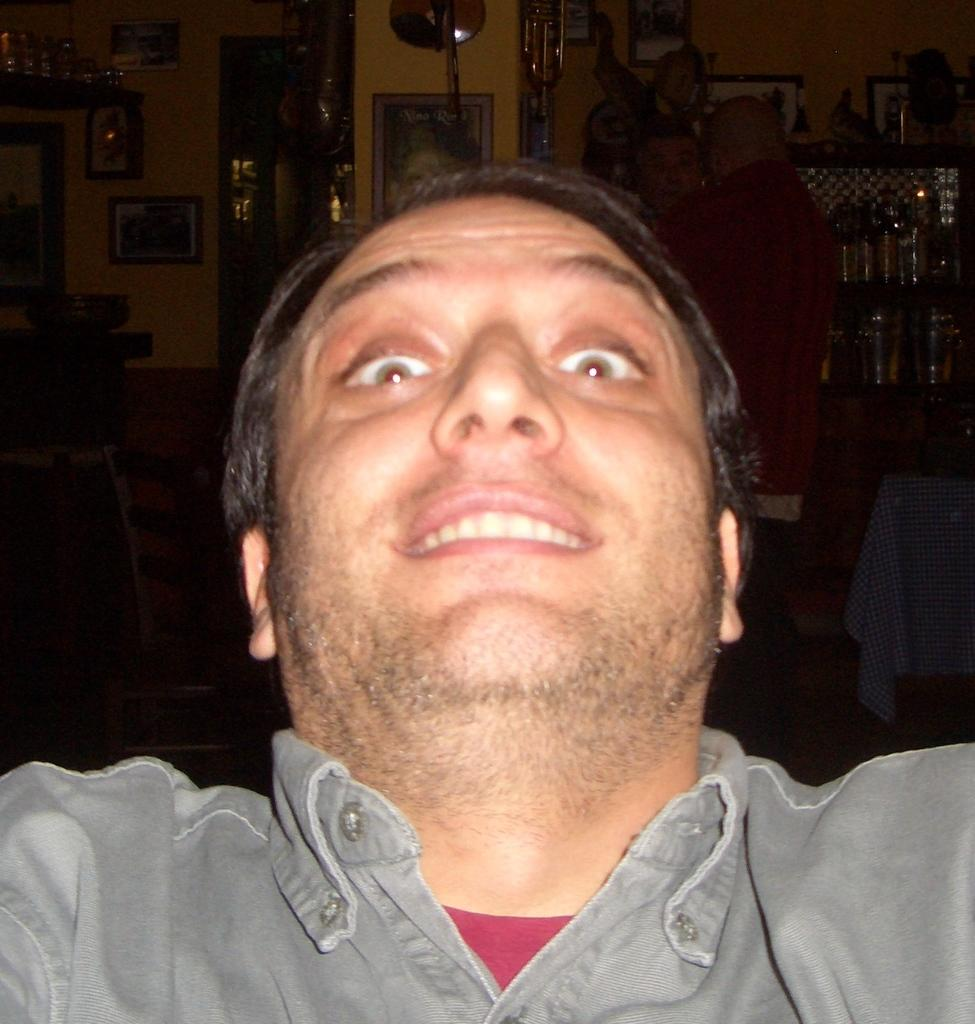Who is present in the image? There is a man in the image. What is the man doing in the image? The man is smiling in the image. What is the man wearing in the image? The man is wearing a grey shirt in the image. What can be seen in the background of the image? There are photos attached to the wall in the background of the image. How would you describe the lighting in the image? The background of the image is dark. What type of cloud is present in the image? There are no clouds present in the image; it is an indoor scene with a dark background. 